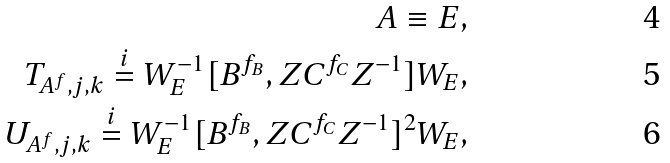<formula> <loc_0><loc_0><loc_500><loc_500>A \equiv E , \\ T _ { A ^ { f } , j , k } \overset { i } = W _ { E } ^ { - 1 } [ B ^ { f _ { B } } , Z C ^ { f _ { C } } Z ^ { - 1 } ] W _ { E } , \\ U _ { A ^ { f } , j , k } \overset { i } = W _ { E } ^ { - 1 } [ B ^ { f _ { B } } , Z C ^ { f _ { C } } Z ^ { - 1 } ] ^ { 2 } W _ { E } ,</formula> 